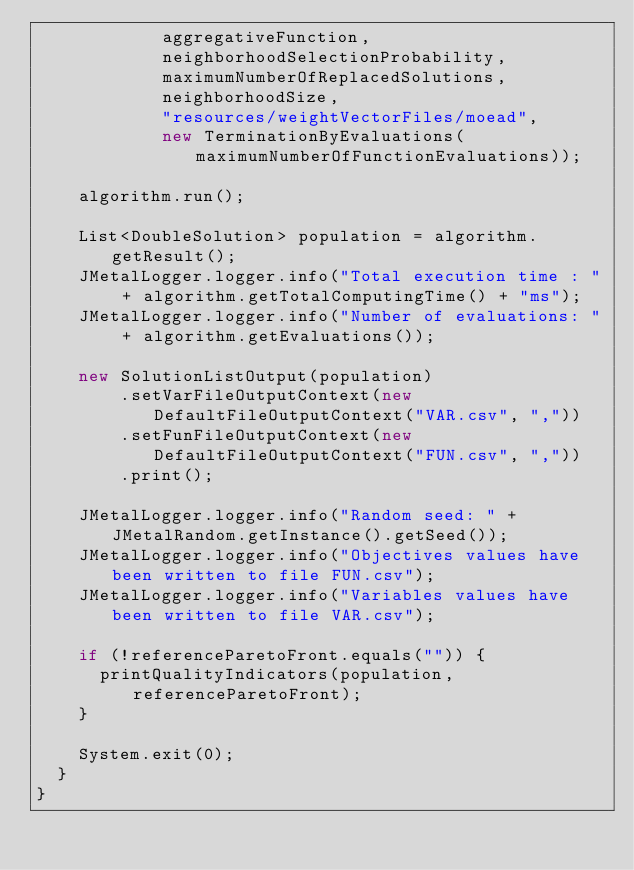Convert code to text. <code><loc_0><loc_0><loc_500><loc_500><_Java_>            aggregativeFunction,
            neighborhoodSelectionProbability,
            maximumNumberOfReplacedSolutions,
            neighborhoodSize,
            "resources/weightVectorFiles/moead",
            new TerminationByEvaluations(maximumNumberOfFunctionEvaluations));

    algorithm.run();

    List<DoubleSolution> population = algorithm.getResult();
    JMetalLogger.logger.info("Total execution time : " + algorithm.getTotalComputingTime() + "ms");
    JMetalLogger.logger.info("Number of evaluations: " + algorithm.getEvaluations());

    new SolutionListOutput(population)
        .setVarFileOutputContext(new DefaultFileOutputContext("VAR.csv", ","))
        .setFunFileOutputContext(new DefaultFileOutputContext("FUN.csv", ","))
        .print();

    JMetalLogger.logger.info("Random seed: " + JMetalRandom.getInstance().getSeed());
    JMetalLogger.logger.info("Objectives values have been written to file FUN.csv");
    JMetalLogger.logger.info("Variables values have been written to file VAR.csv");

    if (!referenceParetoFront.equals("")) {
      printQualityIndicators(population, referenceParetoFront);
    }

    System.exit(0);
  }
}
</code> 